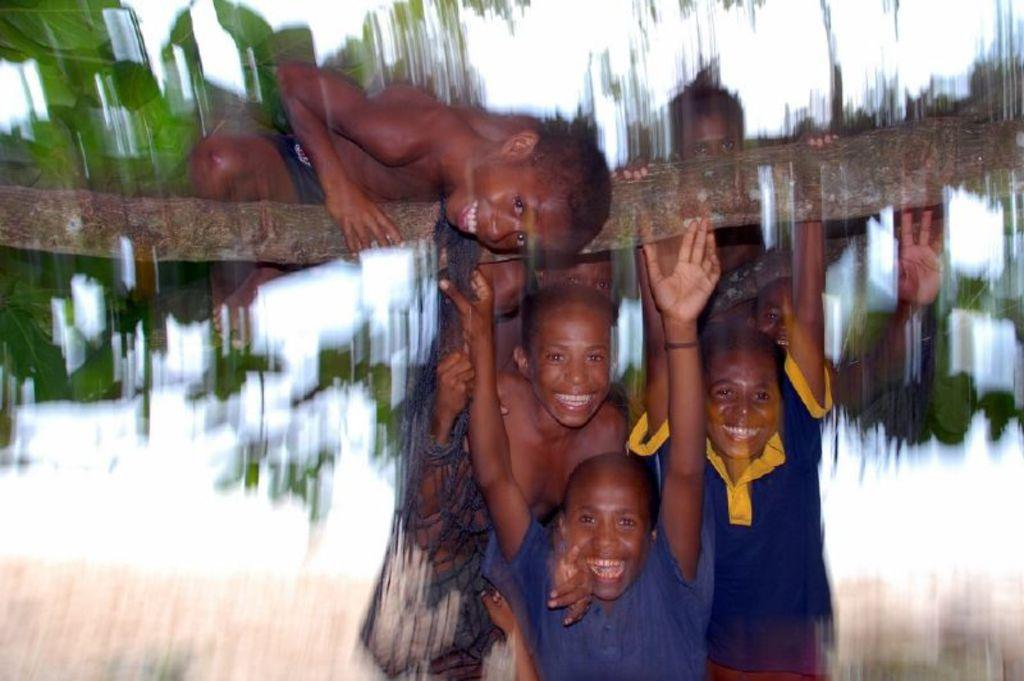What is happening in the image? There is a group of people in the image, and some of them are holding a trunk. Can you describe the background of the image? The background of the image is blurred. What type of bells can be heard ringing in the image? There are no bells present in the image, and therefore no sound can be heard. 